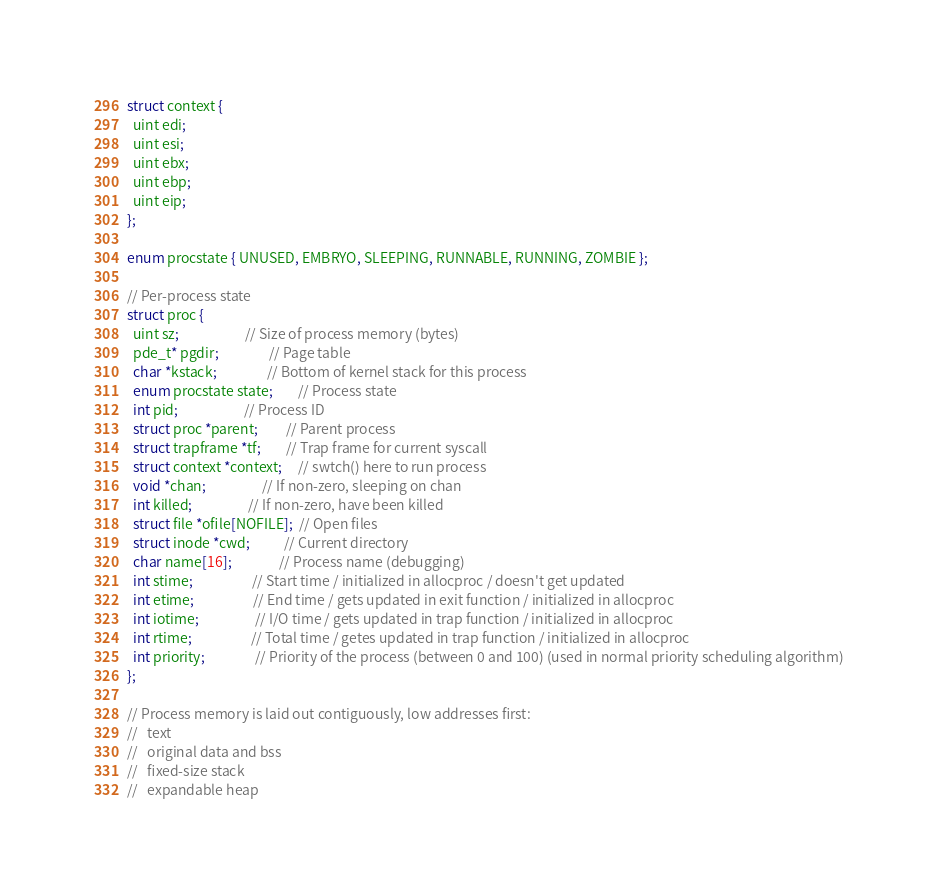Convert code to text. <code><loc_0><loc_0><loc_500><loc_500><_C_>struct context {
  uint edi;
  uint esi;
  uint ebx;
  uint ebp;
  uint eip;
};

enum procstate { UNUSED, EMBRYO, SLEEPING, RUNNABLE, RUNNING, ZOMBIE };

// Per-process state
struct proc {
  uint sz;                     // Size of process memory (bytes)
  pde_t* pgdir;                // Page table
  char *kstack;                // Bottom of kernel stack for this process
  enum procstate state;        // Process state
  int pid;                     // Process ID
  struct proc *parent;         // Parent process
  struct trapframe *tf;        // Trap frame for current syscall
  struct context *context;     // swtch() here to run process
  void *chan;                  // If non-zero, sleeping on chan
  int killed;                  // If non-zero, have been killed
  struct file *ofile[NOFILE];  // Open files
  struct inode *cwd;           // Current directory
  char name[16];               // Process name (debugging)
  int stime;                   // Start time / initialized in allocproc / doesn't get updated
  int etime;                   // End time / gets updated in exit function / initialized in allocproc
  int iotime;                  // I/O time / gets updated in trap function / initialized in allocproc
  int rtime;                   // Total time / getes updated in trap function / initialized in allocproc
  int priority;                // Priority of the process (between 0 and 100) (used in normal priority scheduling algorithm)
};

// Process memory is laid out contiguously, low addresses first:
//   text
//   original data and bss
//   fixed-size stack
//   expandable heap</code> 